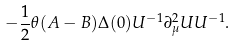<formula> <loc_0><loc_0><loc_500><loc_500>- \frac { 1 } { 2 } \theta ( A - B ) \Delta ( 0 ) U ^ { - 1 } \partial ^ { 2 } _ { \mu } U U ^ { - 1 } .</formula> 